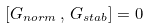<formula> <loc_0><loc_0><loc_500><loc_500>\left [ G _ { n o r m } \, , \, G _ { s t a b } \right ] = 0</formula> 